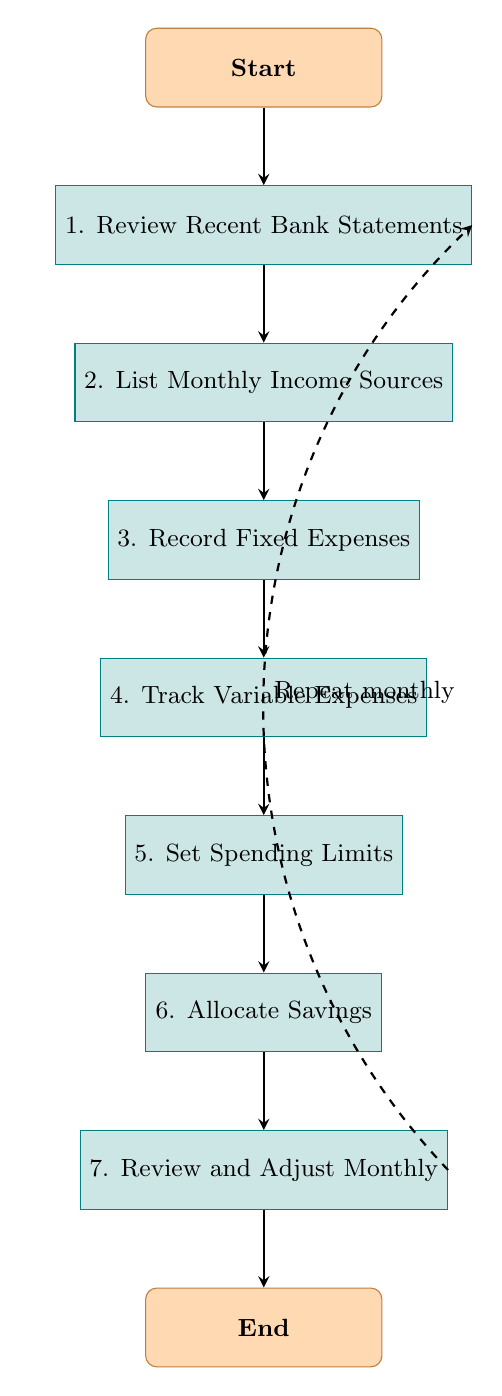What is the first step in managing monthly finances? The first step in the flow chart is labeled "1. Review Recent Bank Statements," which indicates it is the starting point of the finance management process.
Answer: Review Recent Bank Statements How many total steps are in the flow chart? The diagram contains seven distinct steps listed sequentially from the review of bank statements to the adjustment of monthly finances, showing a clear financial management process.
Answer: Seven What follows after tracking variable expenses? After the step "4. Track Variable Expenses," the next step in the flow chart is "5. Set Spending Limits," indicating the sequence of financial management actions.
Answer: Set Spending Limits Which step emphasizes the importance of savings? The step "6. Allocate Savings" specifically focuses on the importance of setting aside a portion of income for emergencies or future needs, highlighting financial prudence.
Answer: Allocate Savings Which step emphasizes the need for regular reviews? The step "7. Review and Adjust Monthly" stresses the importance of regularly reviewing finances and making necessary adjustments to remain on track with financial goals.
Answer: Review and Adjust Monthly If you skip to the end of the process, what should you do? At the end of the flow chart, the final action is to "End," indicating the completion of the monthly finance management process after all prior steps have been followed.
Answer: End How does the flow after "Review and Adjust Monthly" relate to "Review Recent Bank Statements"? After completing the "7. Review and Adjust Monthly" step, you return to "1. Review Recent Bank Statements," indicating that this process is iterative and should be repeated monthly to manage finances effectively.
Answer: Repeat monthly What type of expenses are noted after recording fixed expenses? Following the recording of fixed expenses, the flow chart specifies to "4. Track Variable Expenses," which includes expenses that may vary each month, such as groceries and entertainment.
Answer: Track Variable Expenses 